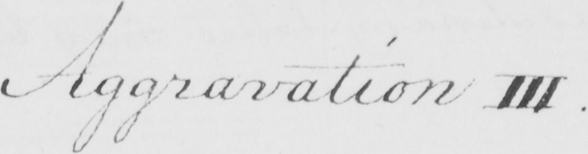Please transcribe the handwritten text in this image. Aggravation III . 